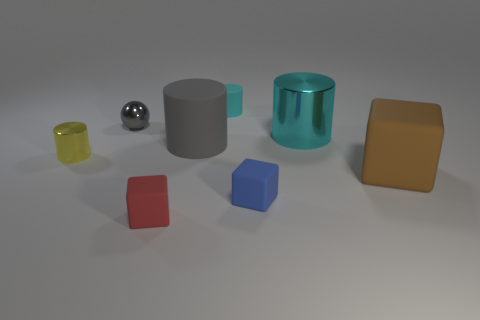The rubber object that is the same size as the brown rubber cube is what shape?
Offer a terse response. Cylinder. There is a gray object that is behind the large cyan metal thing; what is its size?
Ensure brevity in your answer.  Small. There is a small matte cylinder that is behind the gray matte thing; is its color the same as the small metallic thing to the right of the small yellow cylinder?
Offer a very short reply. No. There is a gray thing behind the large rubber object that is on the left side of the block that is right of the small blue cube; what is its material?
Provide a succinct answer. Metal. Are there any blue rubber cubes of the same size as the blue thing?
Your answer should be compact. No. There is a blue thing that is the same size as the red object; what is it made of?
Make the answer very short. Rubber. There is a tiny metal thing right of the tiny shiny cylinder; what is its shape?
Keep it short and to the point. Sphere. Is the big cylinder on the left side of the large cyan object made of the same material as the cyan object that is to the right of the cyan rubber object?
Provide a short and direct response. No. What number of tiny blue rubber things have the same shape as the yellow metallic thing?
Make the answer very short. 0. What material is the thing that is the same color as the tiny ball?
Your answer should be very brief. Rubber. 